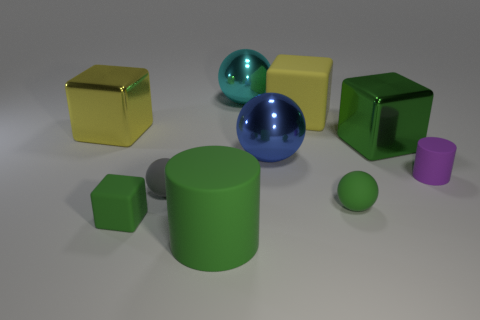What number of objects are either metal objects that are left of the blue object or large green metal cubes to the right of the yellow metallic block?
Your response must be concise. 3. There is a gray object that is the same shape as the cyan thing; what is it made of?
Keep it short and to the point. Rubber. How many metal objects are either small purple cylinders or tiny yellow blocks?
Provide a short and direct response. 0. The purple object that is made of the same material as the green cylinder is what shape?
Offer a very short reply. Cylinder. How many other small purple things have the same shape as the tiny purple thing?
Provide a succinct answer. 0. Is the shape of the big green metal thing that is behind the large cylinder the same as the tiny green rubber thing that is on the right side of the tiny green matte block?
Your answer should be very brief. No. How many things are either big red metallic spheres or green blocks to the left of the tiny gray sphere?
Your answer should be very brief. 1. There is a metallic object that is the same color as the large matte cylinder; what shape is it?
Offer a very short reply. Cube. How many purple things have the same size as the green matte block?
Give a very brief answer. 1. What number of red things are either big metallic spheres or tiny matte cylinders?
Ensure brevity in your answer.  0. 